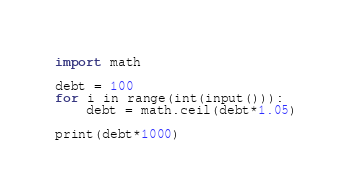<code> <loc_0><loc_0><loc_500><loc_500><_Python_>import math

debt = 100
for i in range(int(input())):
    debt = math.ceil(debt*1.05)

print(debt*1000)</code> 